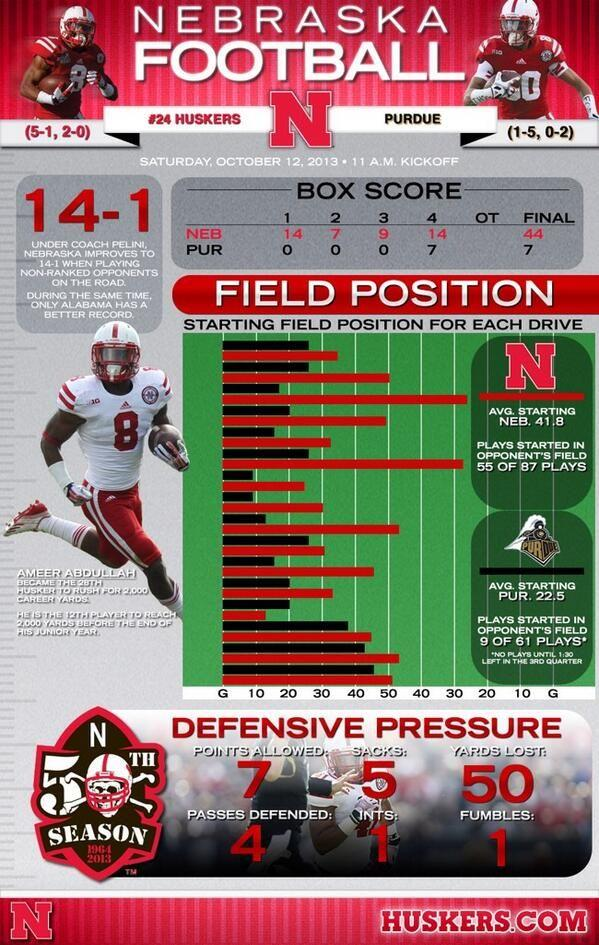Identify some key points in this picture. I lost 50 yards. The points allowed are 7. 